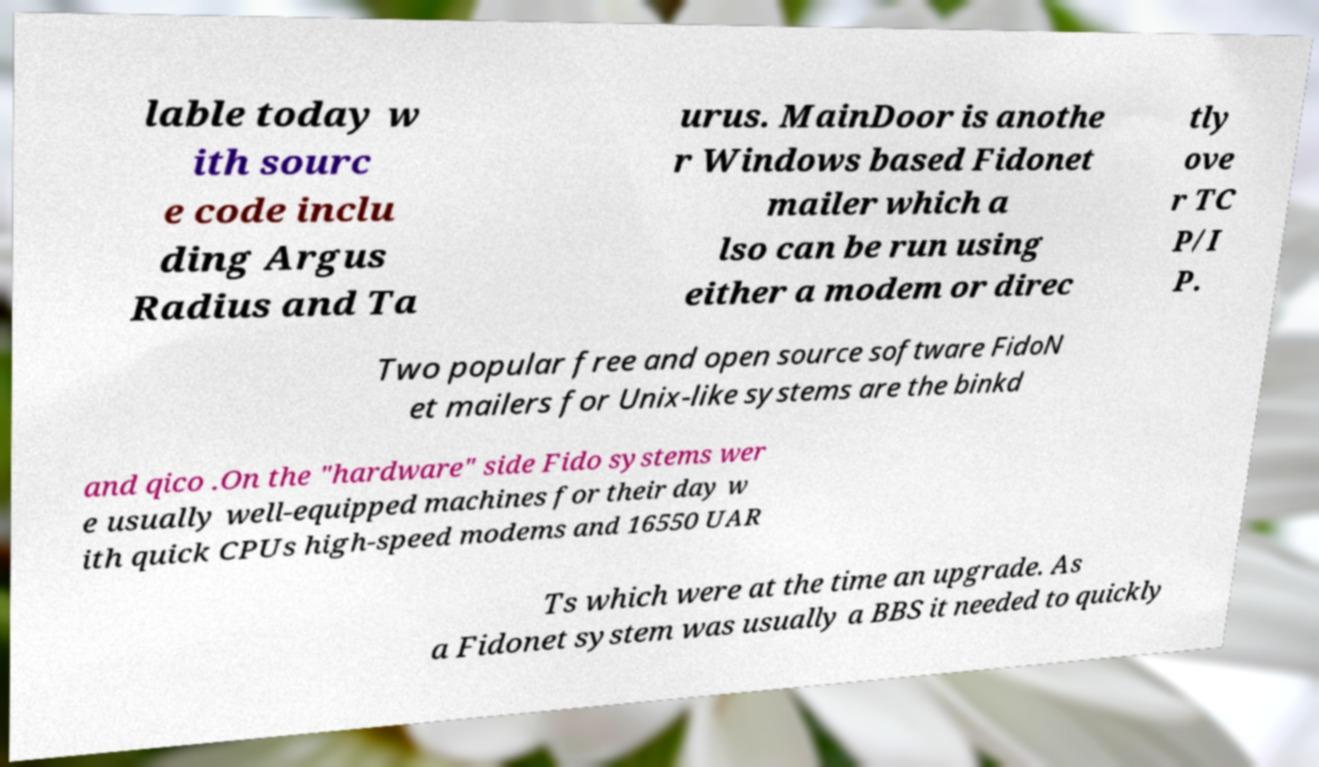Could you extract and type out the text from this image? lable today w ith sourc e code inclu ding Argus Radius and Ta urus. MainDoor is anothe r Windows based Fidonet mailer which a lso can be run using either a modem or direc tly ove r TC P/I P. Two popular free and open source software FidoN et mailers for Unix-like systems are the binkd and qico .On the "hardware" side Fido systems wer e usually well-equipped machines for their day w ith quick CPUs high-speed modems and 16550 UAR Ts which were at the time an upgrade. As a Fidonet system was usually a BBS it needed to quickly 